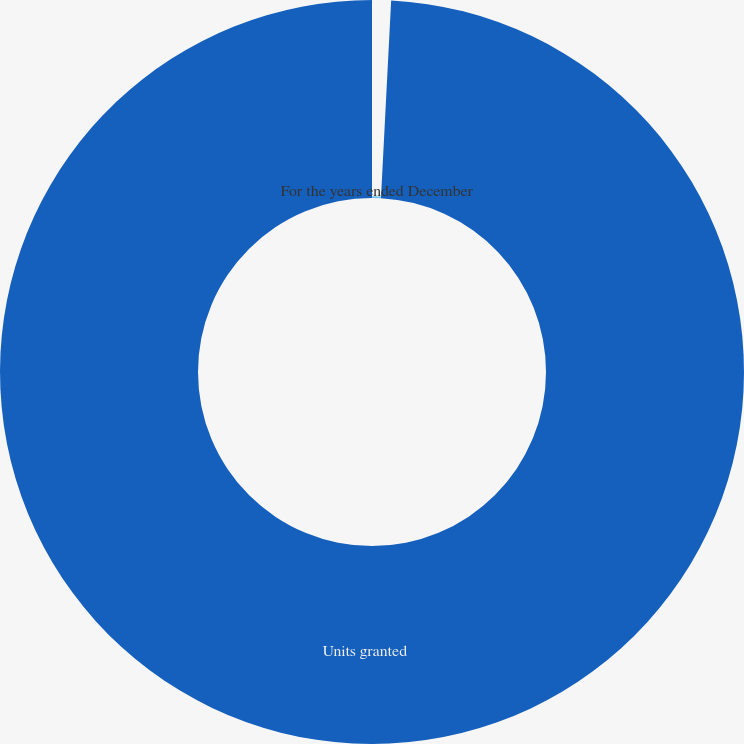<chart> <loc_0><loc_0><loc_500><loc_500><pie_chart><fcel>For the years ended December<fcel>Units granted<nl><fcel>0.82%<fcel>99.18%<nl></chart> 